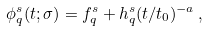Convert formula to latex. <formula><loc_0><loc_0><loc_500><loc_500>\phi ^ { s } _ { q } ( t ; \sigma ) = f ^ { s } _ { q } + h ^ { s } _ { q } ( t / t _ { 0 } ) ^ { - a } \, ,</formula> 